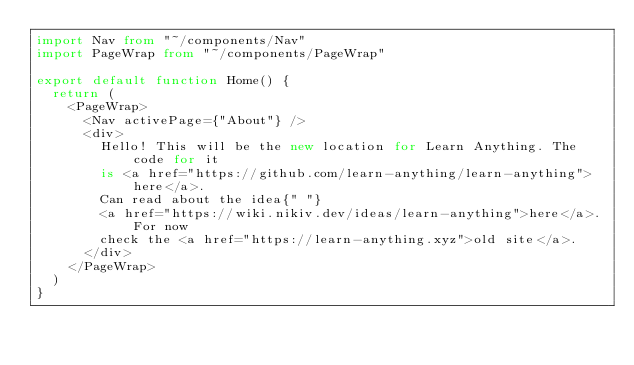Convert code to text. <code><loc_0><loc_0><loc_500><loc_500><_TypeScript_>import Nav from "~/components/Nav"
import PageWrap from "~/components/PageWrap"

export default function Home() {
  return (
    <PageWrap>
      <Nav activePage={"About"} />
      <div>
        Hello! This will be the new location for Learn Anything. The code for it
        is <a href="https://github.com/learn-anything/learn-anything">here</a>.
        Can read about the idea{" "}
        <a href="https://wiki.nikiv.dev/ideas/learn-anything">here</a>. For now
        check the <a href="https://learn-anything.xyz">old site</a>.
      </div>
    </PageWrap>
  )
}
</code> 